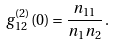<formula> <loc_0><loc_0><loc_500><loc_500>g _ { 1 2 } ^ { ( 2 ) } ( 0 ) = \frac { n _ { 1 1 } } { n _ { 1 } n _ { 2 } } \, .</formula> 